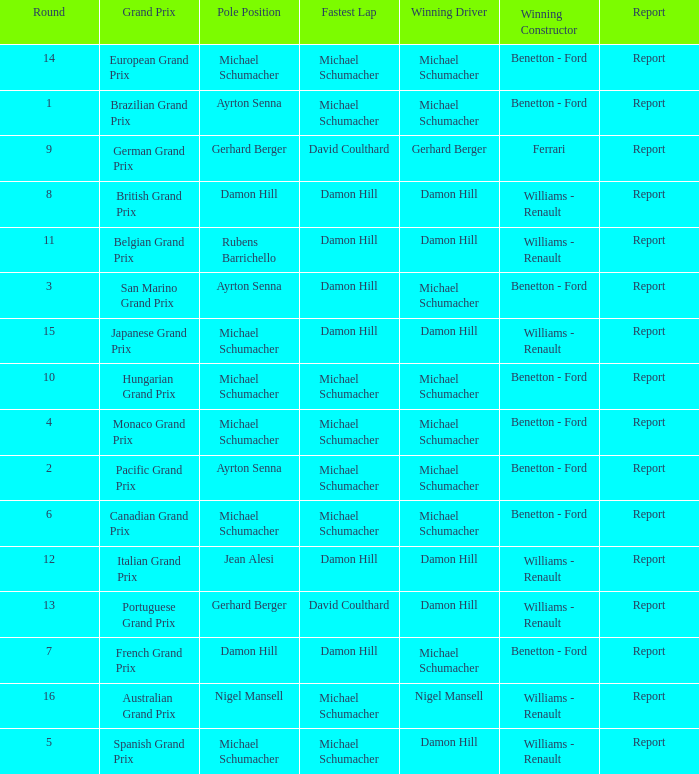Name the lowest round for when pole position and winning driver is michael schumacher 4.0. 